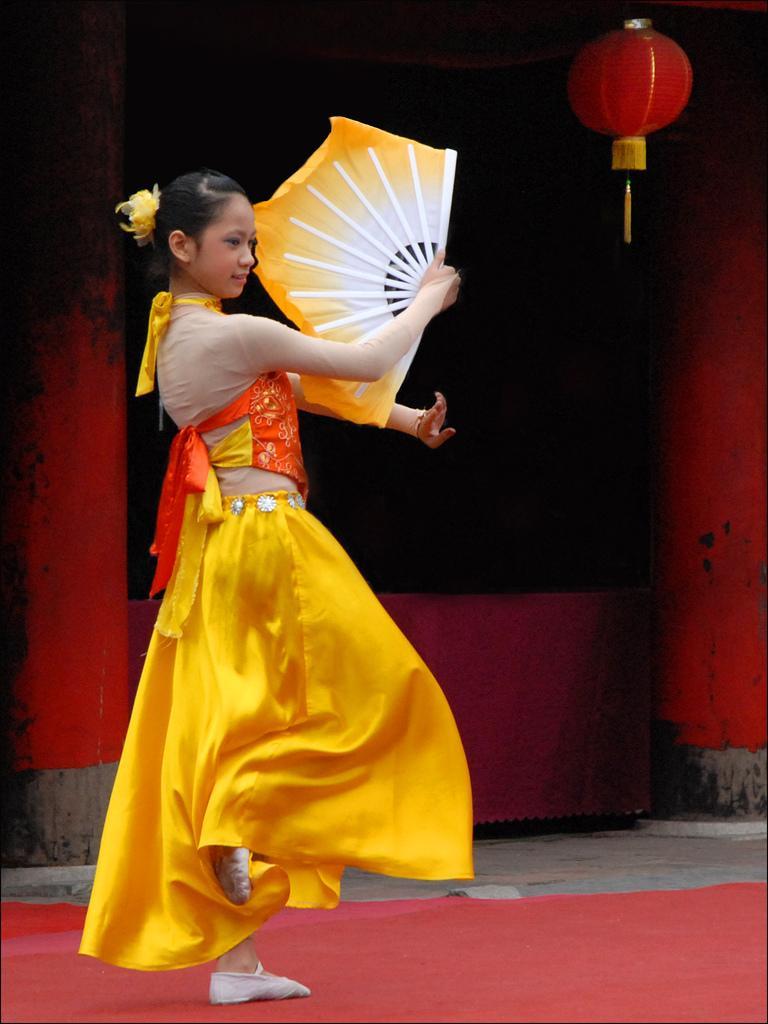Could you give a brief overview of what you see in this image? In the image we can see there is a girl standing and holding a hand fan in her hand. She is wearing a yellow colour dress and standing on the red carpet kept on the ground. 